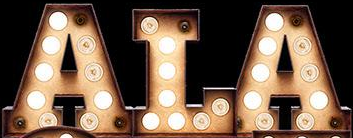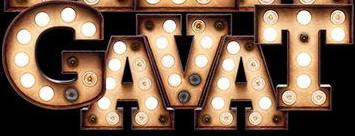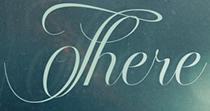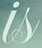What words can you see in these images in sequence, separated by a semicolon? ALA; GAVAT; There; is 